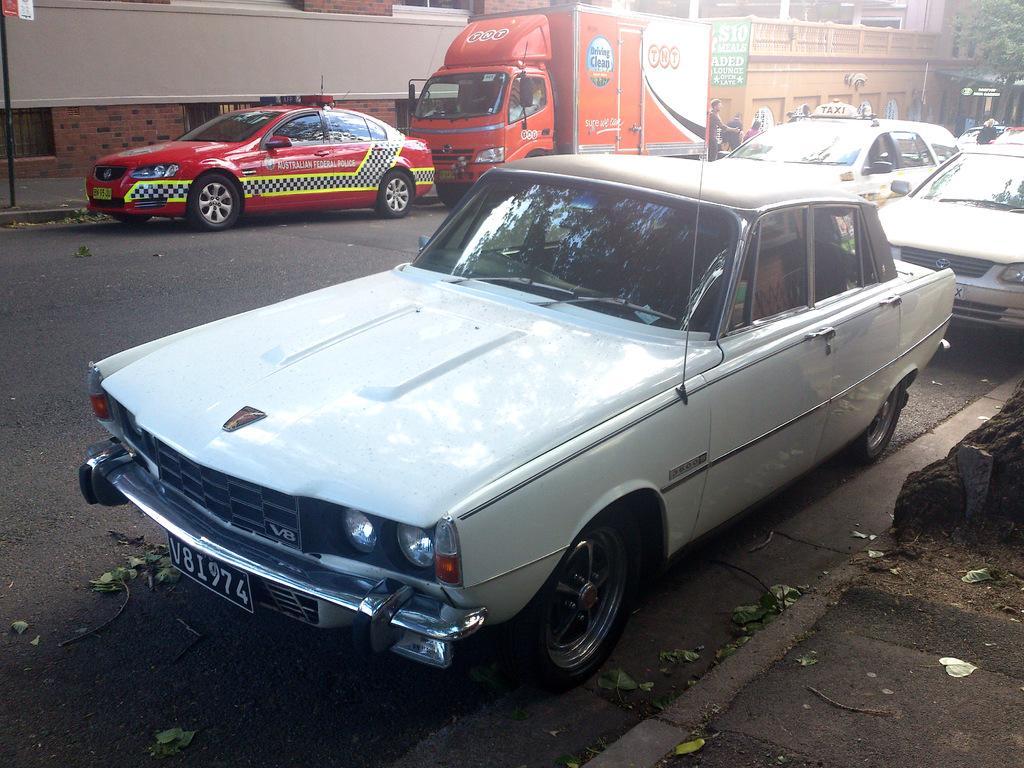How would you summarize this image in a sentence or two? In this image we can see few cars on the road, a person standing near the vehicle, there are buildings, tree and a poster attached to the building. 